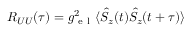Convert formula to latex. <formula><loc_0><loc_0><loc_500><loc_500>R _ { U U } ( \tau ) = g _ { e l } ^ { 2 } \langle \hat { S } _ { z } ( t ) \hat { S } _ { z } ( t + \tau ) \rangle</formula> 